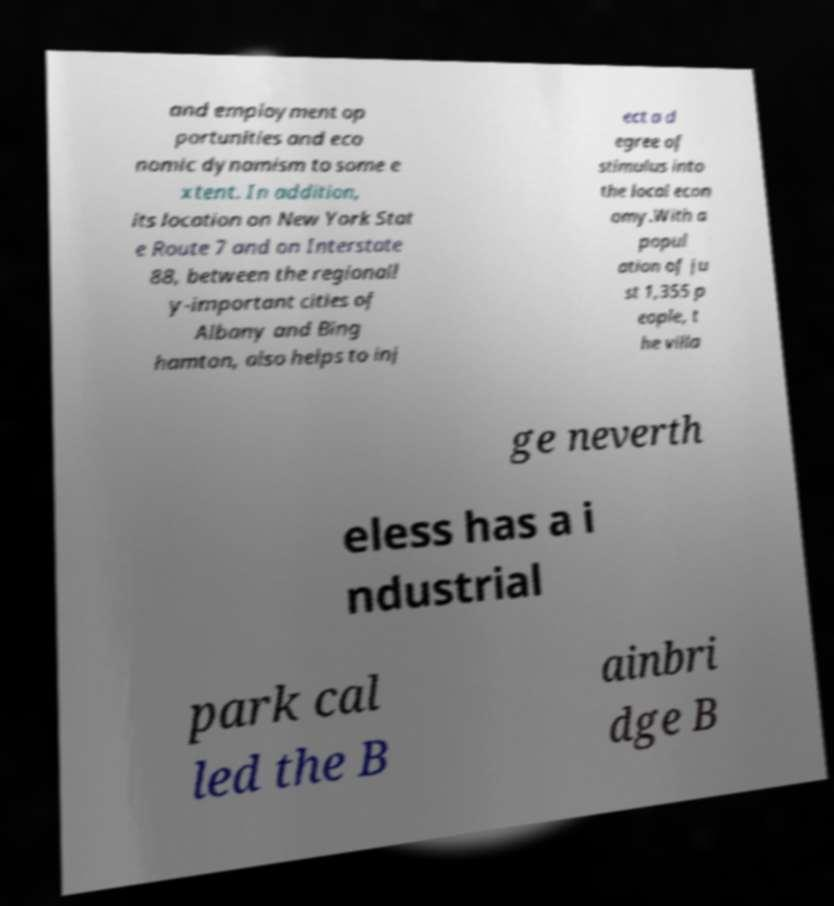Please identify and transcribe the text found in this image. and employment op portunities and eco nomic dynamism to some e xtent. In addition, its location on New York Stat e Route 7 and on Interstate 88, between the regionall y-important cities of Albany and Bing hamton, also helps to inj ect a d egree of stimulus into the local econ omy.With a popul ation of ju st 1,355 p eople, t he villa ge neverth eless has a i ndustrial park cal led the B ainbri dge B 